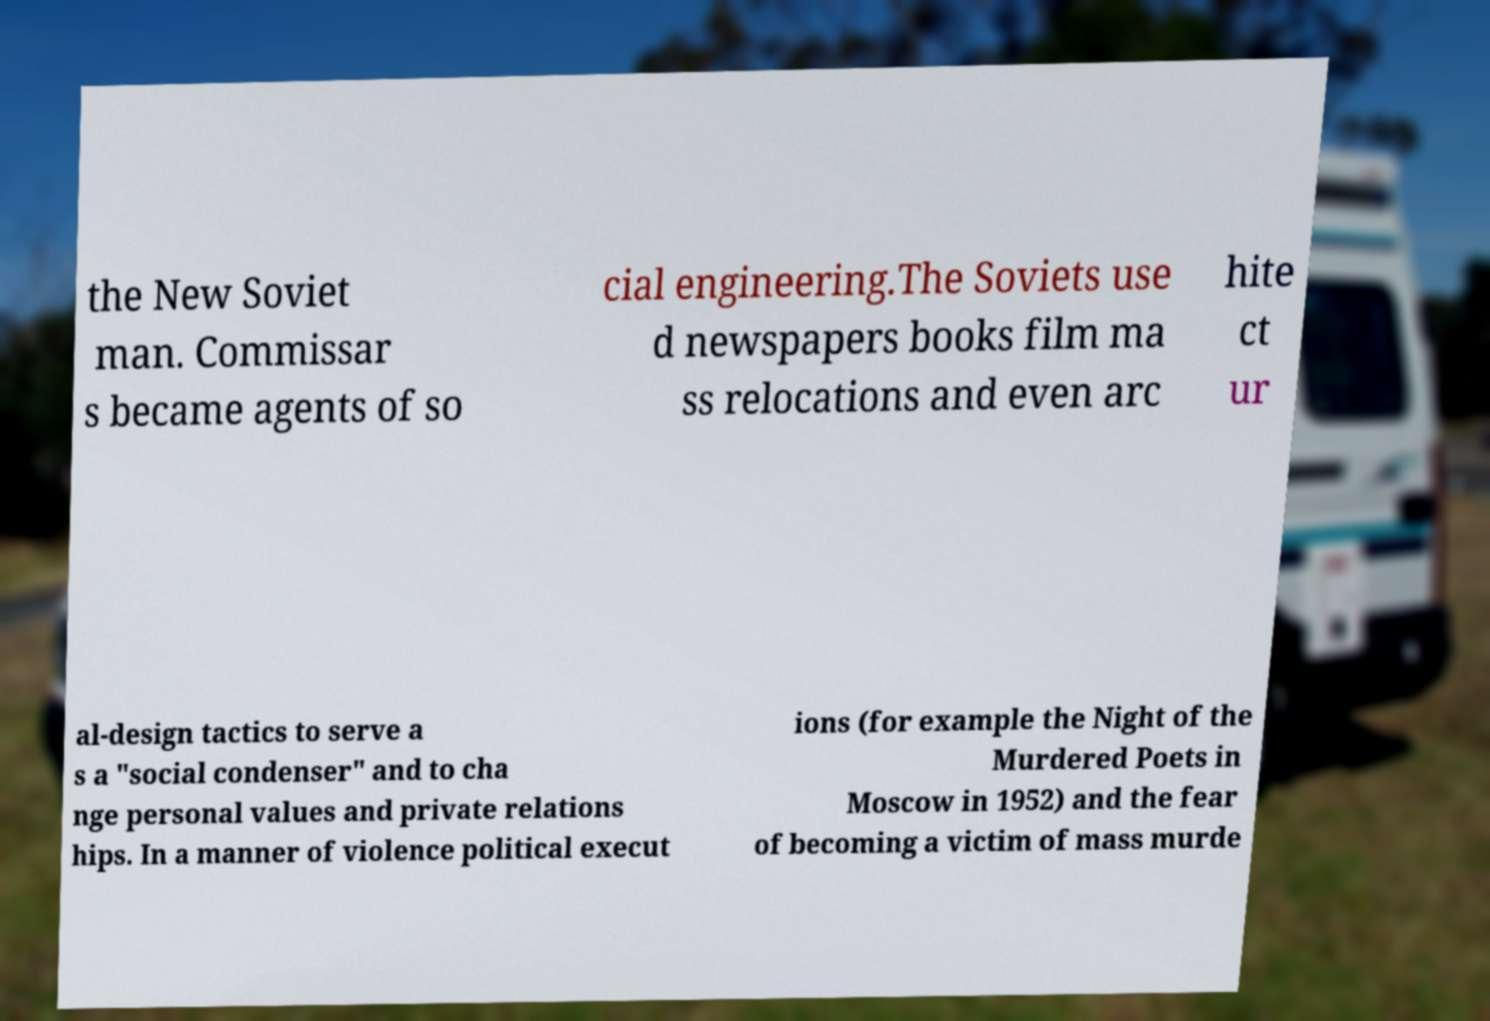Could you extract and type out the text from this image? the New Soviet man. Commissar s became agents of so cial engineering.The Soviets use d newspapers books film ma ss relocations and even arc hite ct ur al-design tactics to serve a s a "social condenser" and to cha nge personal values and private relations hips. In a manner of violence political execut ions (for example the Night of the Murdered Poets in Moscow in 1952) and the fear of becoming a victim of mass murde 